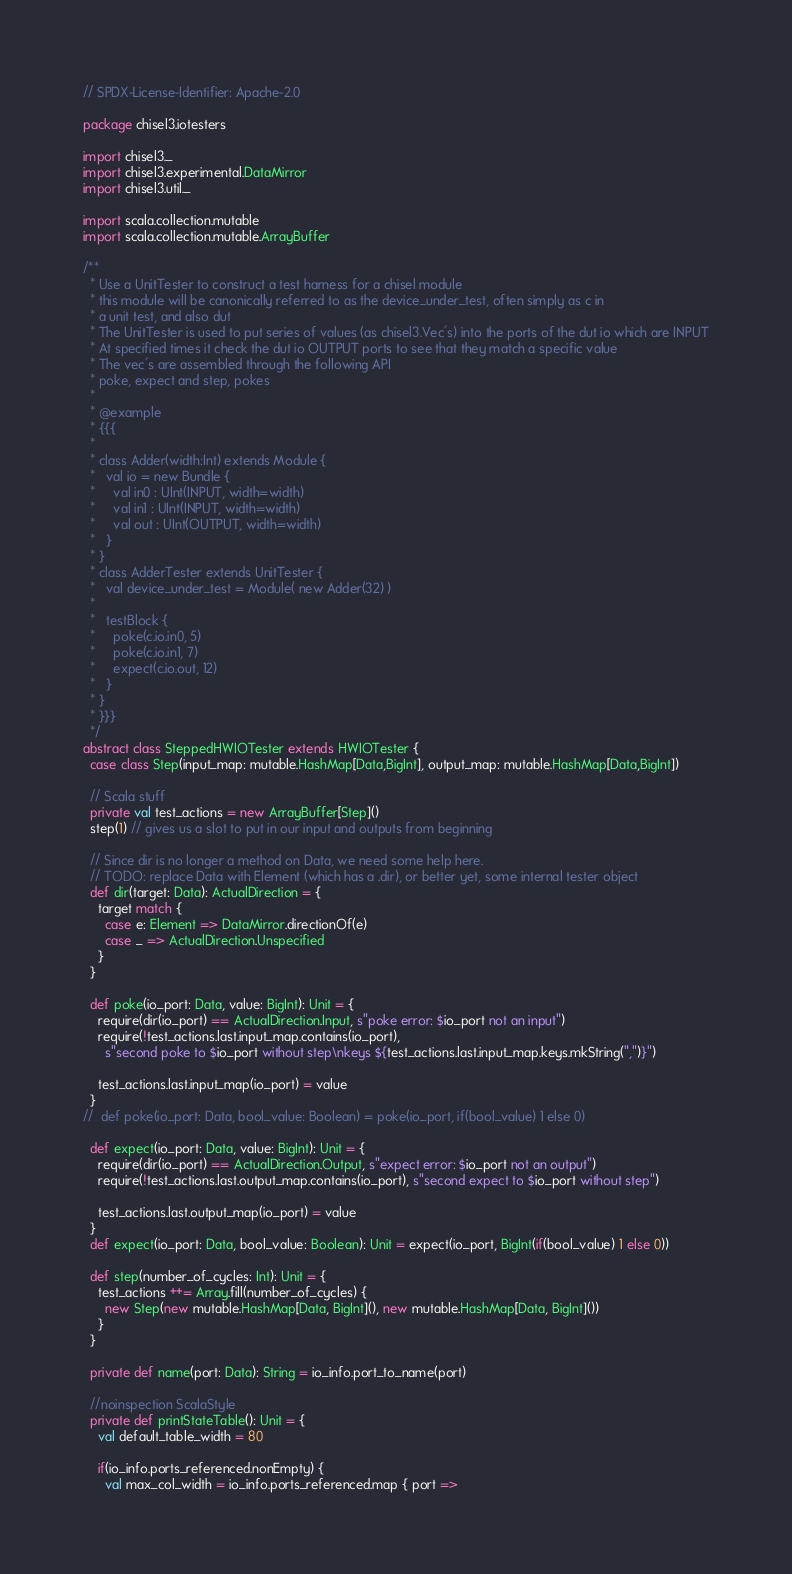Convert code to text. <code><loc_0><loc_0><loc_500><loc_500><_Scala_>// SPDX-License-Identifier: Apache-2.0

package chisel3.iotesters

import chisel3._
import chisel3.experimental.DataMirror
import chisel3.util._

import scala.collection.mutable
import scala.collection.mutable.ArrayBuffer

/**
  * Use a UnitTester to construct a test harness for a chisel module
  * this module will be canonically referred to as the device_under_test, often simply as c in
  * a unit test, and also dut
  * The UnitTester is used to put series of values (as chisel3.Vec's) into the ports of the dut io which are INPUT
  * At specified times it check the dut io OUTPUT ports to see that they match a specific value
  * The vec's are assembled through the following API
  * poke, expect and step, pokes
  *
  * @example
  * {{{
  *
  * class Adder(width:Int) extends Module {
  *   val io = new Bundle {
  *     val in0 : UInt(INPUT, width=width)
  *     val in1 : UInt(INPUT, width=width)
  *     val out : UInt(OUTPUT, width=width)
  *   }
  * }
  * class AdderTester extends UnitTester {
  *   val device_under_test = Module( new Adder(32) )
  *
  *   testBlock {
  *     poke(c.io.in0, 5)
  *     poke(c.io.in1, 7)
  *     expect(c.io.out, 12)
  *   }
  * }
  * }}}
  */
abstract class SteppedHWIOTester extends HWIOTester {
  case class Step(input_map: mutable.HashMap[Data,BigInt], output_map: mutable.HashMap[Data,BigInt])

  // Scala stuff
  private val test_actions = new ArrayBuffer[Step]()
  step(1) // gives us a slot to put in our input and outputs from beginning

  // Since dir is no longer a method on Data, we need some help here.
  // TODO: replace Data with Element (which has a .dir), or better yet, some internal tester object
  def dir(target: Data): ActualDirection = {
    target match {
      case e: Element => DataMirror.directionOf(e)
      case _ => ActualDirection.Unspecified
    }
  }

  def poke(io_port: Data, value: BigInt): Unit = {
    require(dir(io_port) == ActualDirection.Input, s"poke error: $io_port not an input")
    require(!test_actions.last.input_map.contains(io_port),
      s"second poke to $io_port without step\nkeys ${test_actions.last.input_map.keys.mkString(",")}")

    test_actions.last.input_map(io_port) = value
  }
//  def poke(io_port: Data, bool_value: Boolean) = poke(io_port, if(bool_value) 1 else 0)

  def expect(io_port: Data, value: BigInt): Unit = {
    require(dir(io_port) == ActualDirection.Output, s"expect error: $io_port not an output")
    require(!test_actions.last.output_map.contains(io_port), s"second expect to $io_port without step")

    test_actions.last.output_map(io_port) = value
  }
  def expect(io_port: Data, bool_value: Boolean): Unit = expect(io_port, BigInt(if(bool_value) 1 else 0))

  def step(number_of_cycles: Int): Unit = {
    test_actions ++= Array.fill(number_of_cycles) {
      new Step(new mutable.HashMap[Data, BigInt](), new mutable.HashMap[Data, BigInt]())
    }
  }

  private def name(port: Data): String = io_info.port_to_name(port)

  //noinspection ScalaStyle
  private def printStateTable(): Unit = {
    val default_table_width = 80

    if(io_info.ports_referenced.nonEmpty) {
      val max_col_width = io_info.ports_referenced.map { port =></code> 